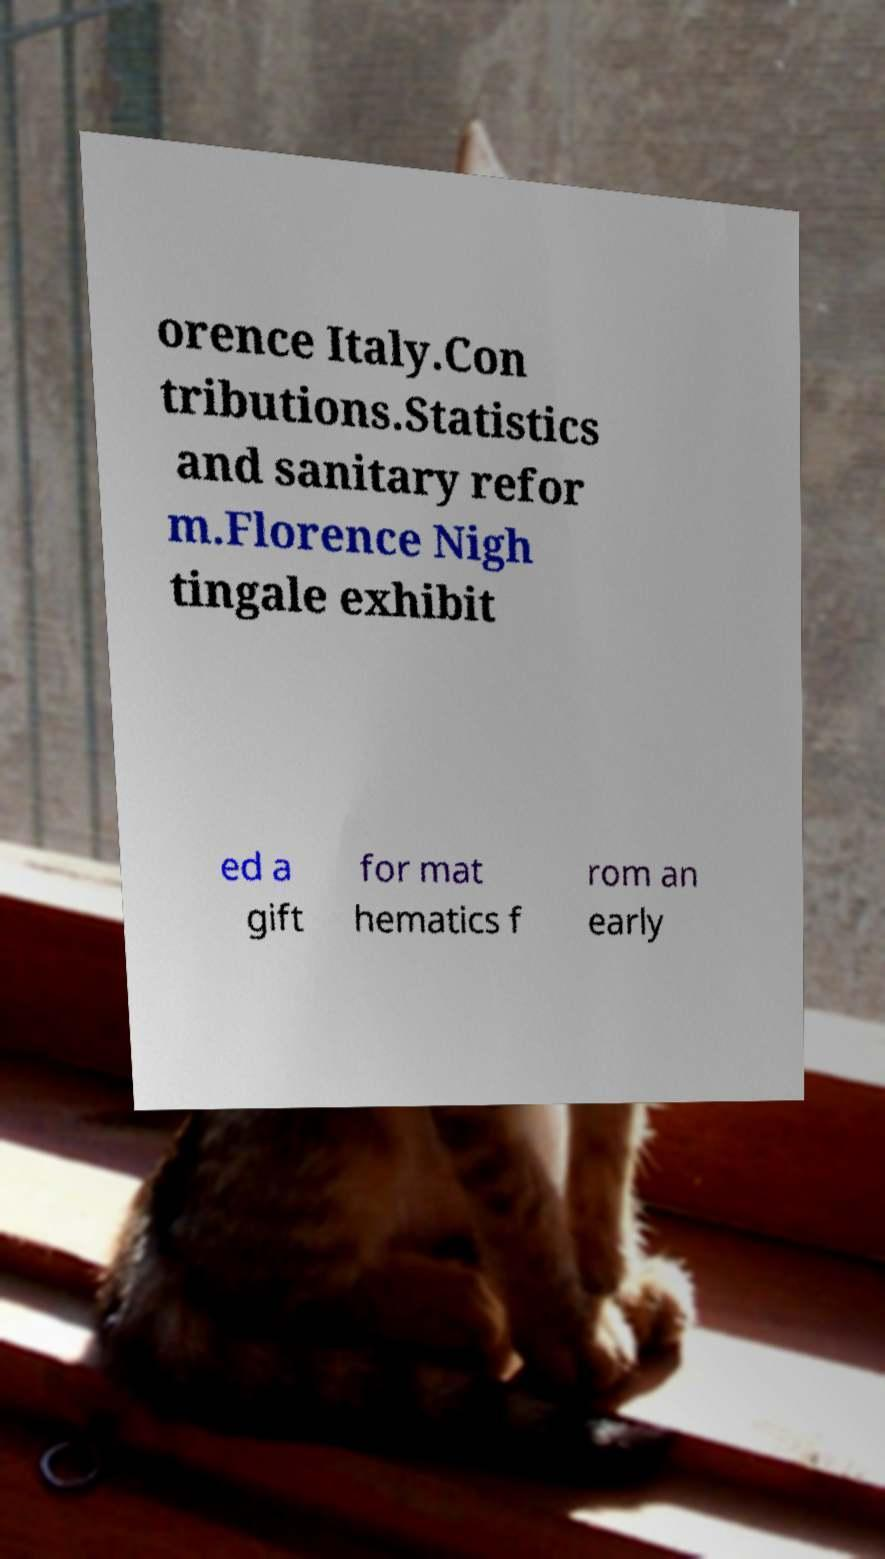Could you assist in decoding the text presented in this image and type it out clearly? orence Italy.Con tributions.Statistics and sanitary refor m.Florence Nigh tingale exhibit ed a gift for mat hematics f rom an early 